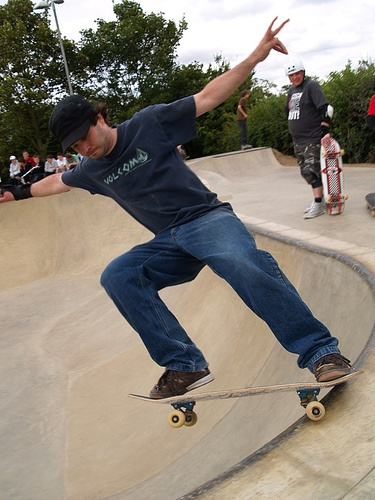Describe the objects in this image and their specific colors. I can see people in white, black, navy, blue, and gray tones, people in white, black, gray, lightgray, and darkgray tones, skateboard in white, tan, and black tones, skateboard in white, darkgray, lightgray, gray, and brown tones, and people in white, black, darkgreen, maroon, and gray tones in this image. 